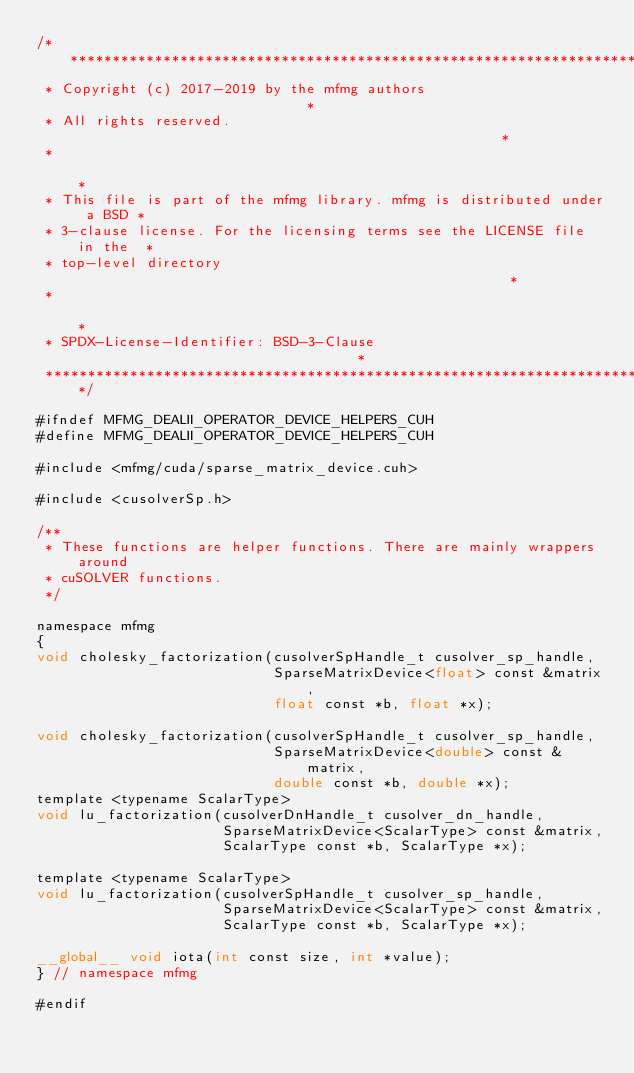Convert code to text. <code><loc_0><loc_0><loc_500><loc_500><_Cuda_>/**************************************************************************
 * Copyright (c) 2017-2019 by the mfmg authors                            *
 * All rights reserved.                                                   *
 *                                                                        *
 * This file is part of the mfmg library. mfmg is distributed under a BSD *
 * 3-clause license. For the licensing terms see the LICENSE file in the  *
 * top-level directory                                                    *
 *                                                                        *
 * SPDX-License-Identifier: BSD-3-Clause                                  *
 *************************************************************************/

#ifndef MFMG_DEALII_OPERATOR_DEVICE_HELPERS_CUH
#define MFMG_DEALII_OPERATOR_DEVICE_HELPERS_CUH

#include <mfmg/cuda/sparse_matrix_device.cuh>

#include <cusolverSp.h>

/**
 * These functions are helper functions. There are mainly wrappers around
 * cuSOLVER functions.
 */

namespace mfmg
{
void cholesky_factorization(cusolverSpHandle_t cusolver_sp_handle,
                            SparseMatrixDevice<float> const &matrix,
                            float const *b, float *x);

void cholesky_factorization(cusolverSpHandle_t cusolver_sp_handle,
                            SparseMatrixDevice<double> const &matrix,
                            double const *b, double *x);
template <typename ScalarType>
void lu_factorization(cusolverDnHandle_t cusolver_dn_handle,
                      SparseMatrixDevice<ScalarType> const &matrix,
                      ScalarType const *b, ScalarType *x);

template <typename ScalarType>
void lu_factorization(cusolverSpHandle_t cusolver_sp_handle,
                      SparseMatrixDevice<ScalarType> const &matrix,
                      ScalarType const *b, ScalarType *x);

__global__ void iota(int const size, int *value);
} // namespace mfmg

#endif
</code> 